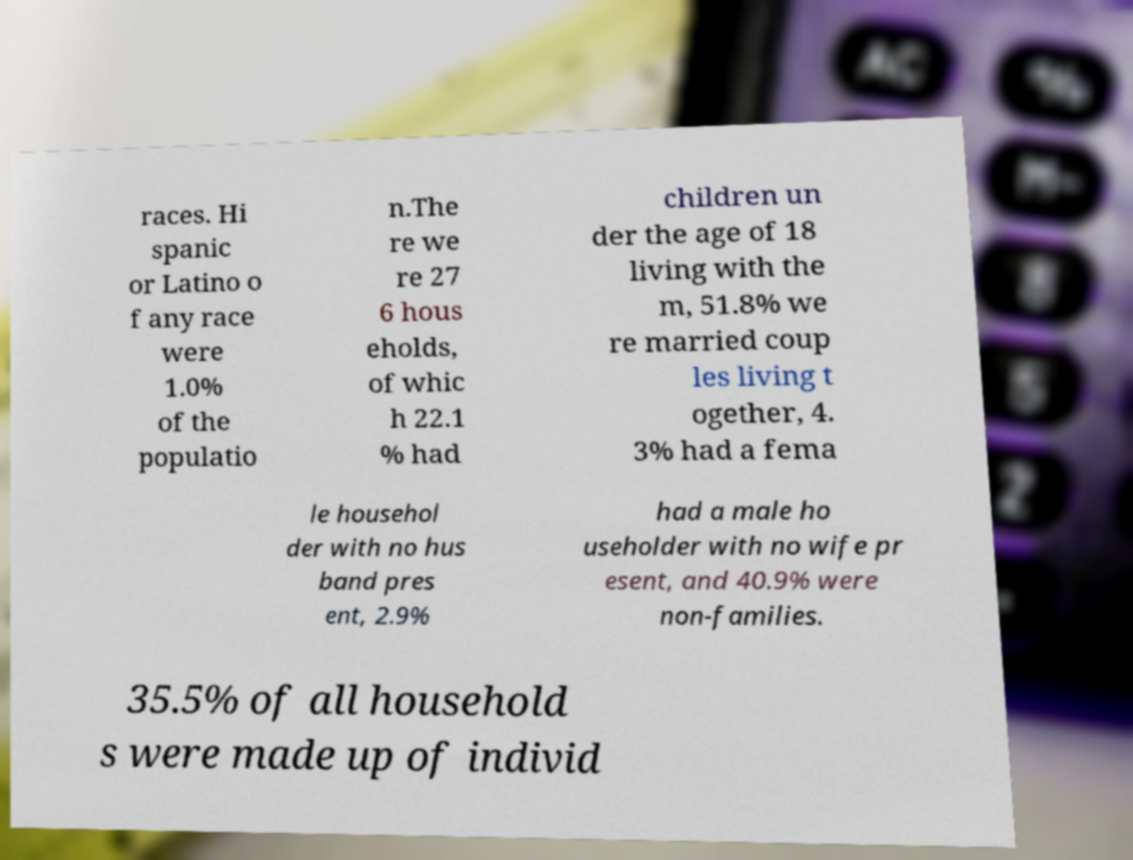For documentation purposes, I need the text within this image transcribed. Could you provide that? races. Hi spanic or Latino o f any race were 1.0% of the populatio n.The re we re 27 6 hous eholds, of whic h 22.1 % had children un der the age of 18 living with the m, 51.8% we re married coup les living t ogether, 4. 3% had a fema le househol der with no hus band pres ent, 2.9% had a male ho useholder with no wife pr esent, and 40.9% were non-families. 35.5% of all household s were made up of individ 